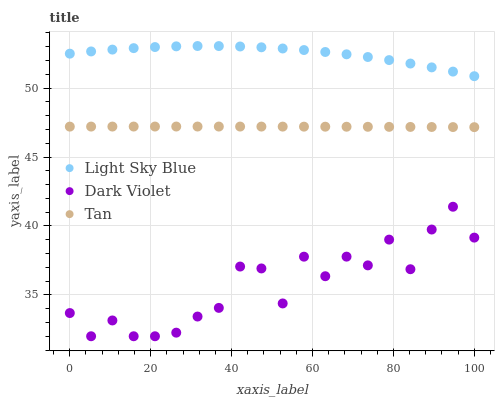Does Dark Violet have the minimum area under the curve?
Answer yes or no. Yes. Does Light Sky Blue have the maximum area under the curve?
Answer yes or no. Yes. Does Light Sky Blue have the minimum area under the curve?
Answer yes or no. No. Does Dark Violet have the maximum area under the curve?
Answer yes or no. No. Is Tan the smoothest?
Answer yes or no. Yes. Is Dark Violet the roughest?
Answer yes or no. Yes. Is Light Sky Blue the smoothest?
Answer yes or no. No. Is Light Sky Blue the roughest?
Answer yes or no. No. Does Dark Violet have the lowest value?
Answer yes or no. Yes. Does Light Sky Blue have the lowest value?
Answer yes or no. No. Does Light Sky Blue have the highest value?
Answer yes or no. Yes. Does Dark Violet have the highest value?
Answer yes or no. No. Is Dark Violet less than Tan?
Answer yes or no. Yes. Is Tan greater than Dark Violet?
Answer yes or no. Yes. Does Dark Violet intersect Tan?
Answer yes or no. No. 